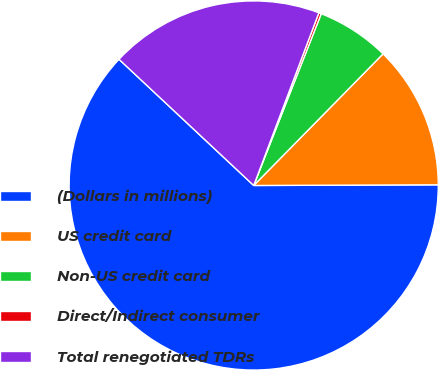Convert chart. <chart><loc_0><loc_0><loc_500><loc_500><pie_chart><fcel>(Dollars in millions)<fcel>US credit card<fcel>Non-US credit card<fcel>Direct/Indirect consumer<fcel>Total renegotiated TDRs<nl><fcel>62.04%<fcel>12.58%<fcel>6.4%<fcel>0.22%<fcel>18.76%<nl></chart> 